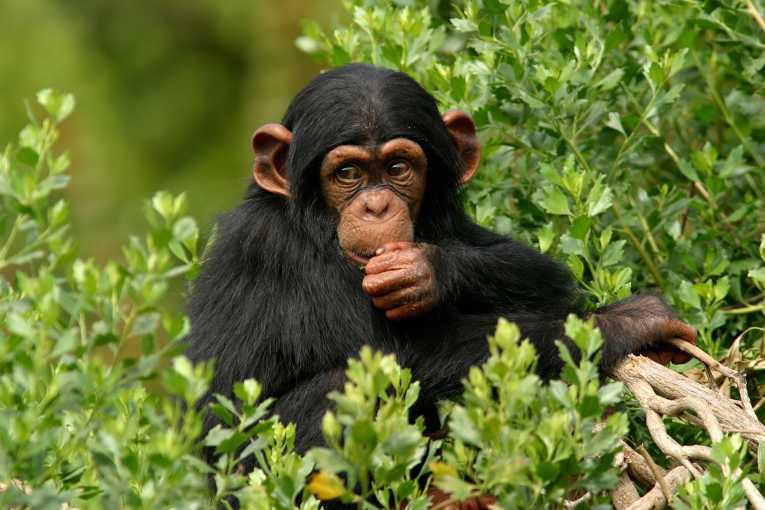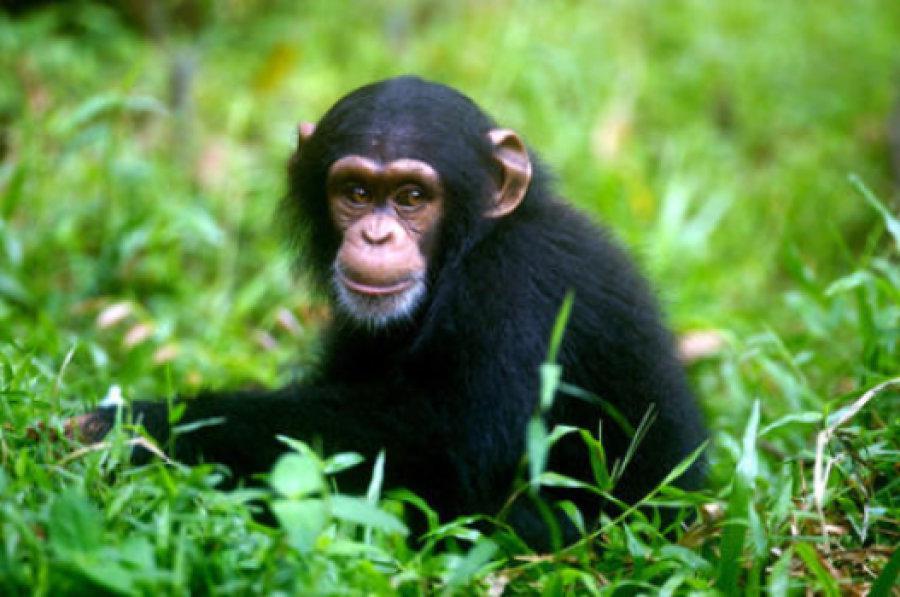The first image is the image on the left, the second image is the image on the right. Evaluate the accuracy of this statement regarding the images: "There are two monkeys in the image on the right.". Is it true? Answer yes or no. No. 